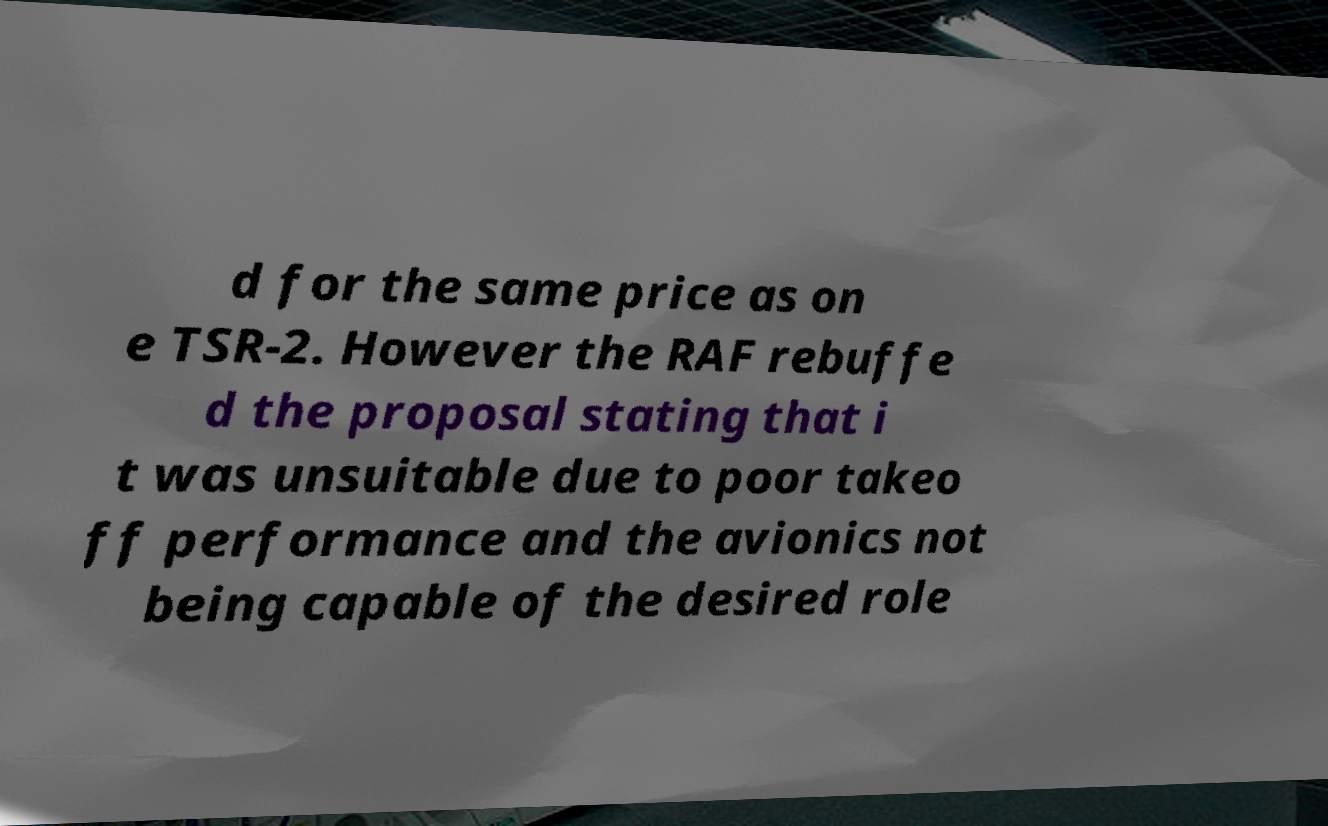Please identify and transcribe the text found in this image. d for the same price as on e TSR-2. However the RAF rebuffe d the proposal stating that i t was unsuitable due to poor takeo ff performance and the avionics not being capable of the desired role 